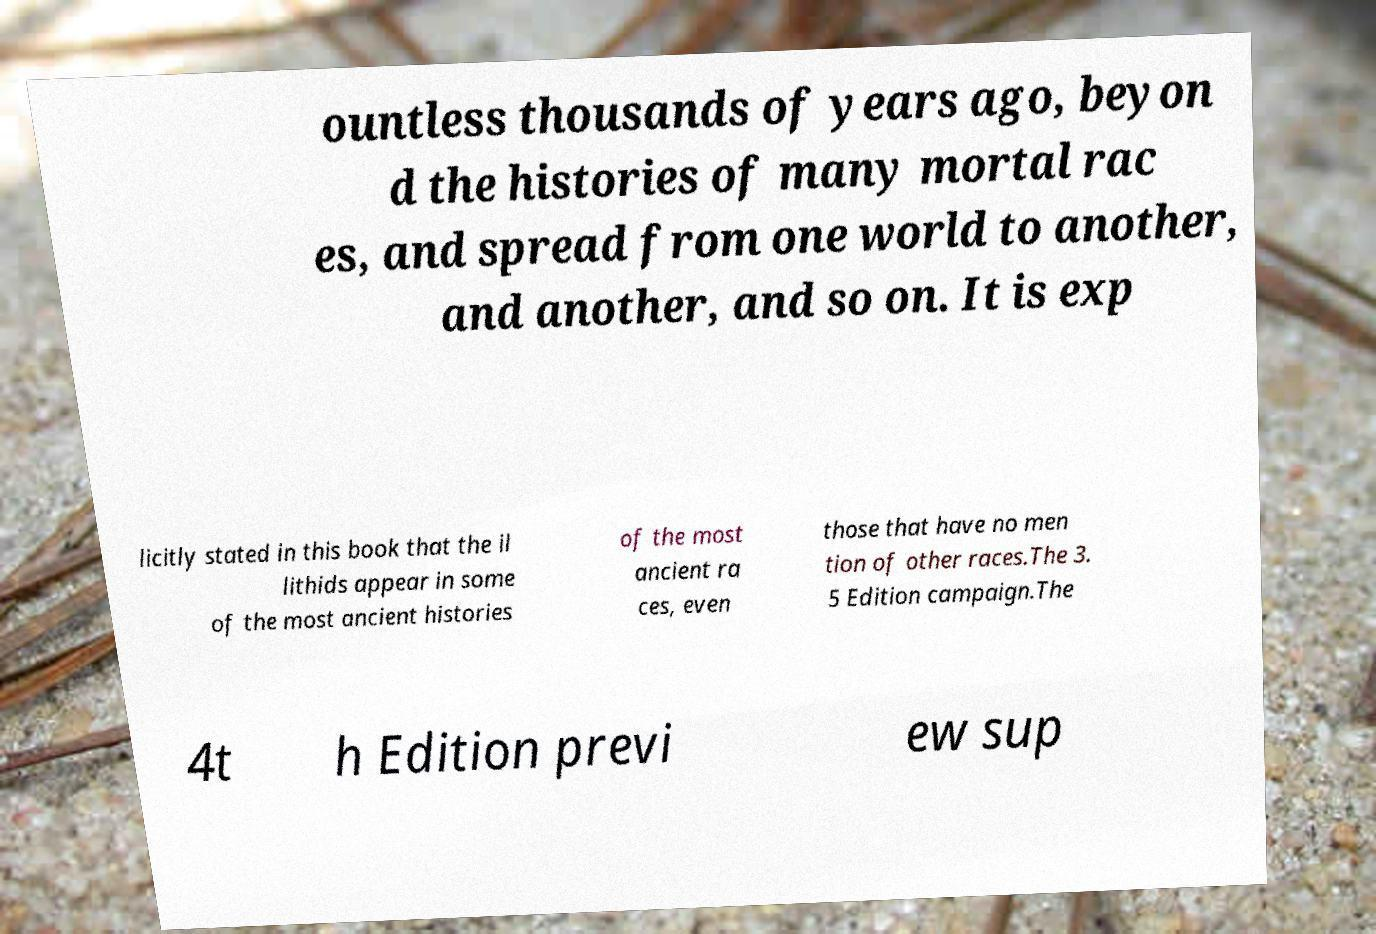Please identify and transcribe the text found in this image. ountless thousands of years ago, beyon d the histories of many mortal rac es, and spread from one world to another, and another, and so on. It is exp licitly stated in this book that the il lithids appear in some of the most ancient histories of the most ancient ra ces, even those that have no men tion of other races.The 3. 5 Edition campaign.The 4t h Edition previ ew sup 